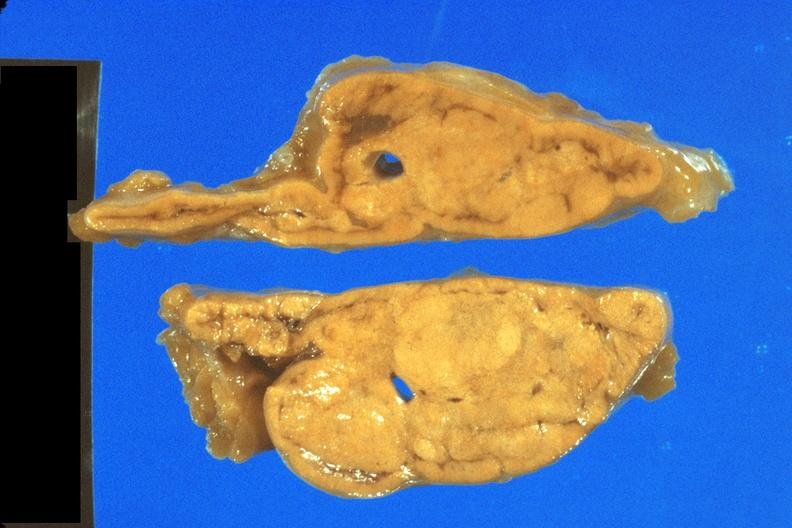what is present?
Answer the question using a single word or phrase. Endocrine 